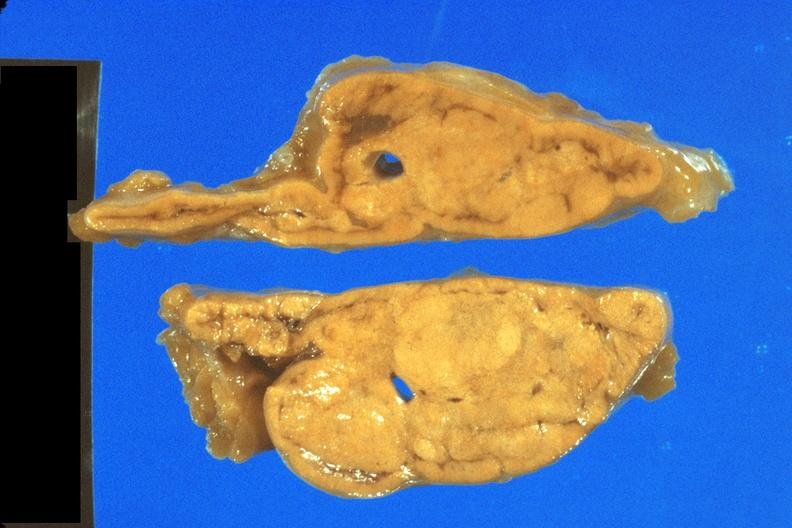what is present?
Answer the question using a single word or phrase. Endocrine 